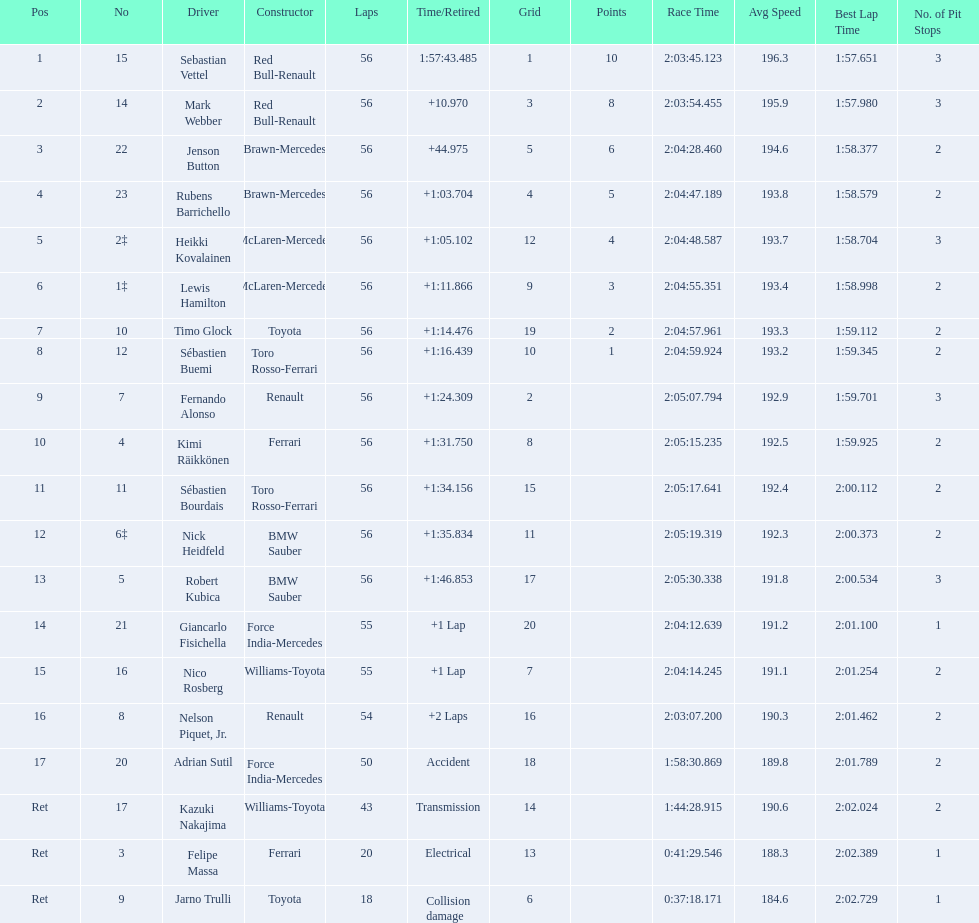How many drivers did not finish 56 laps? 7. 